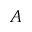Convert formula to latex. <formula><loc_0><loc_0><loc_500><loc_500>A</formula> 